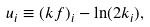<formula> <loc_0><loc_0><loc_500><loc_500>u _ { i } \equiv ( k f ) _ { i } - \ln ( 2 k _ { i } ) ,</formula> 